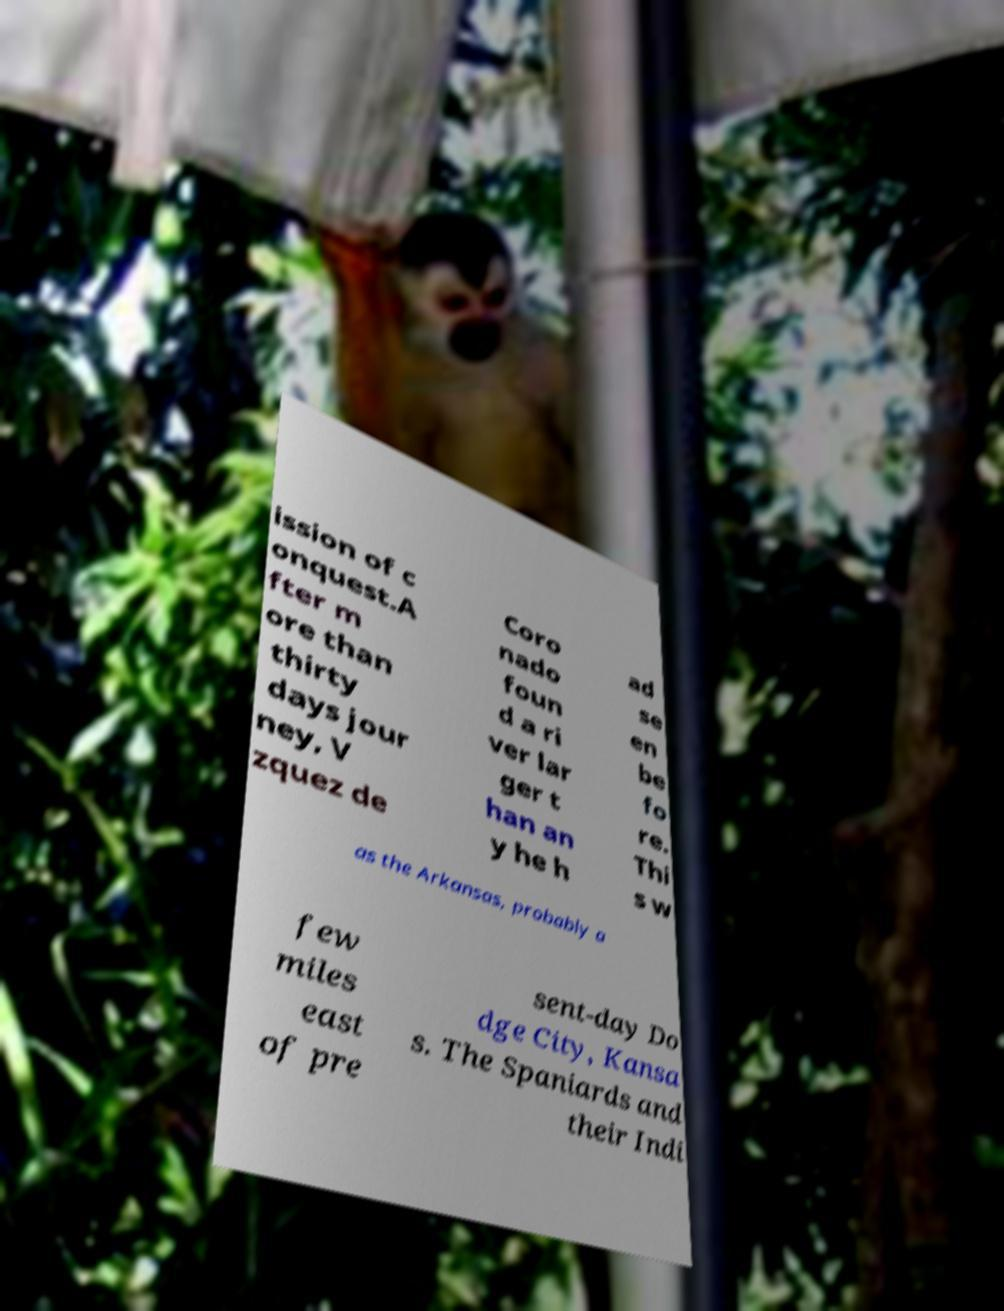For documentation purposes, I need the text within this image transcribed. Could you provide that? ission of c onquest.A fter m ore than thirty days jour ney, V zquez de Coro nado foun d a ri ver lar ger t han an y he h ad se en be fo re. Thi s w as the Arkansas, probably a few miles east of pre sent-day Do dge City, Kansa s. The Spaniards and their Indi 